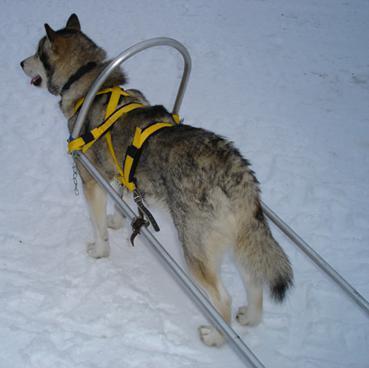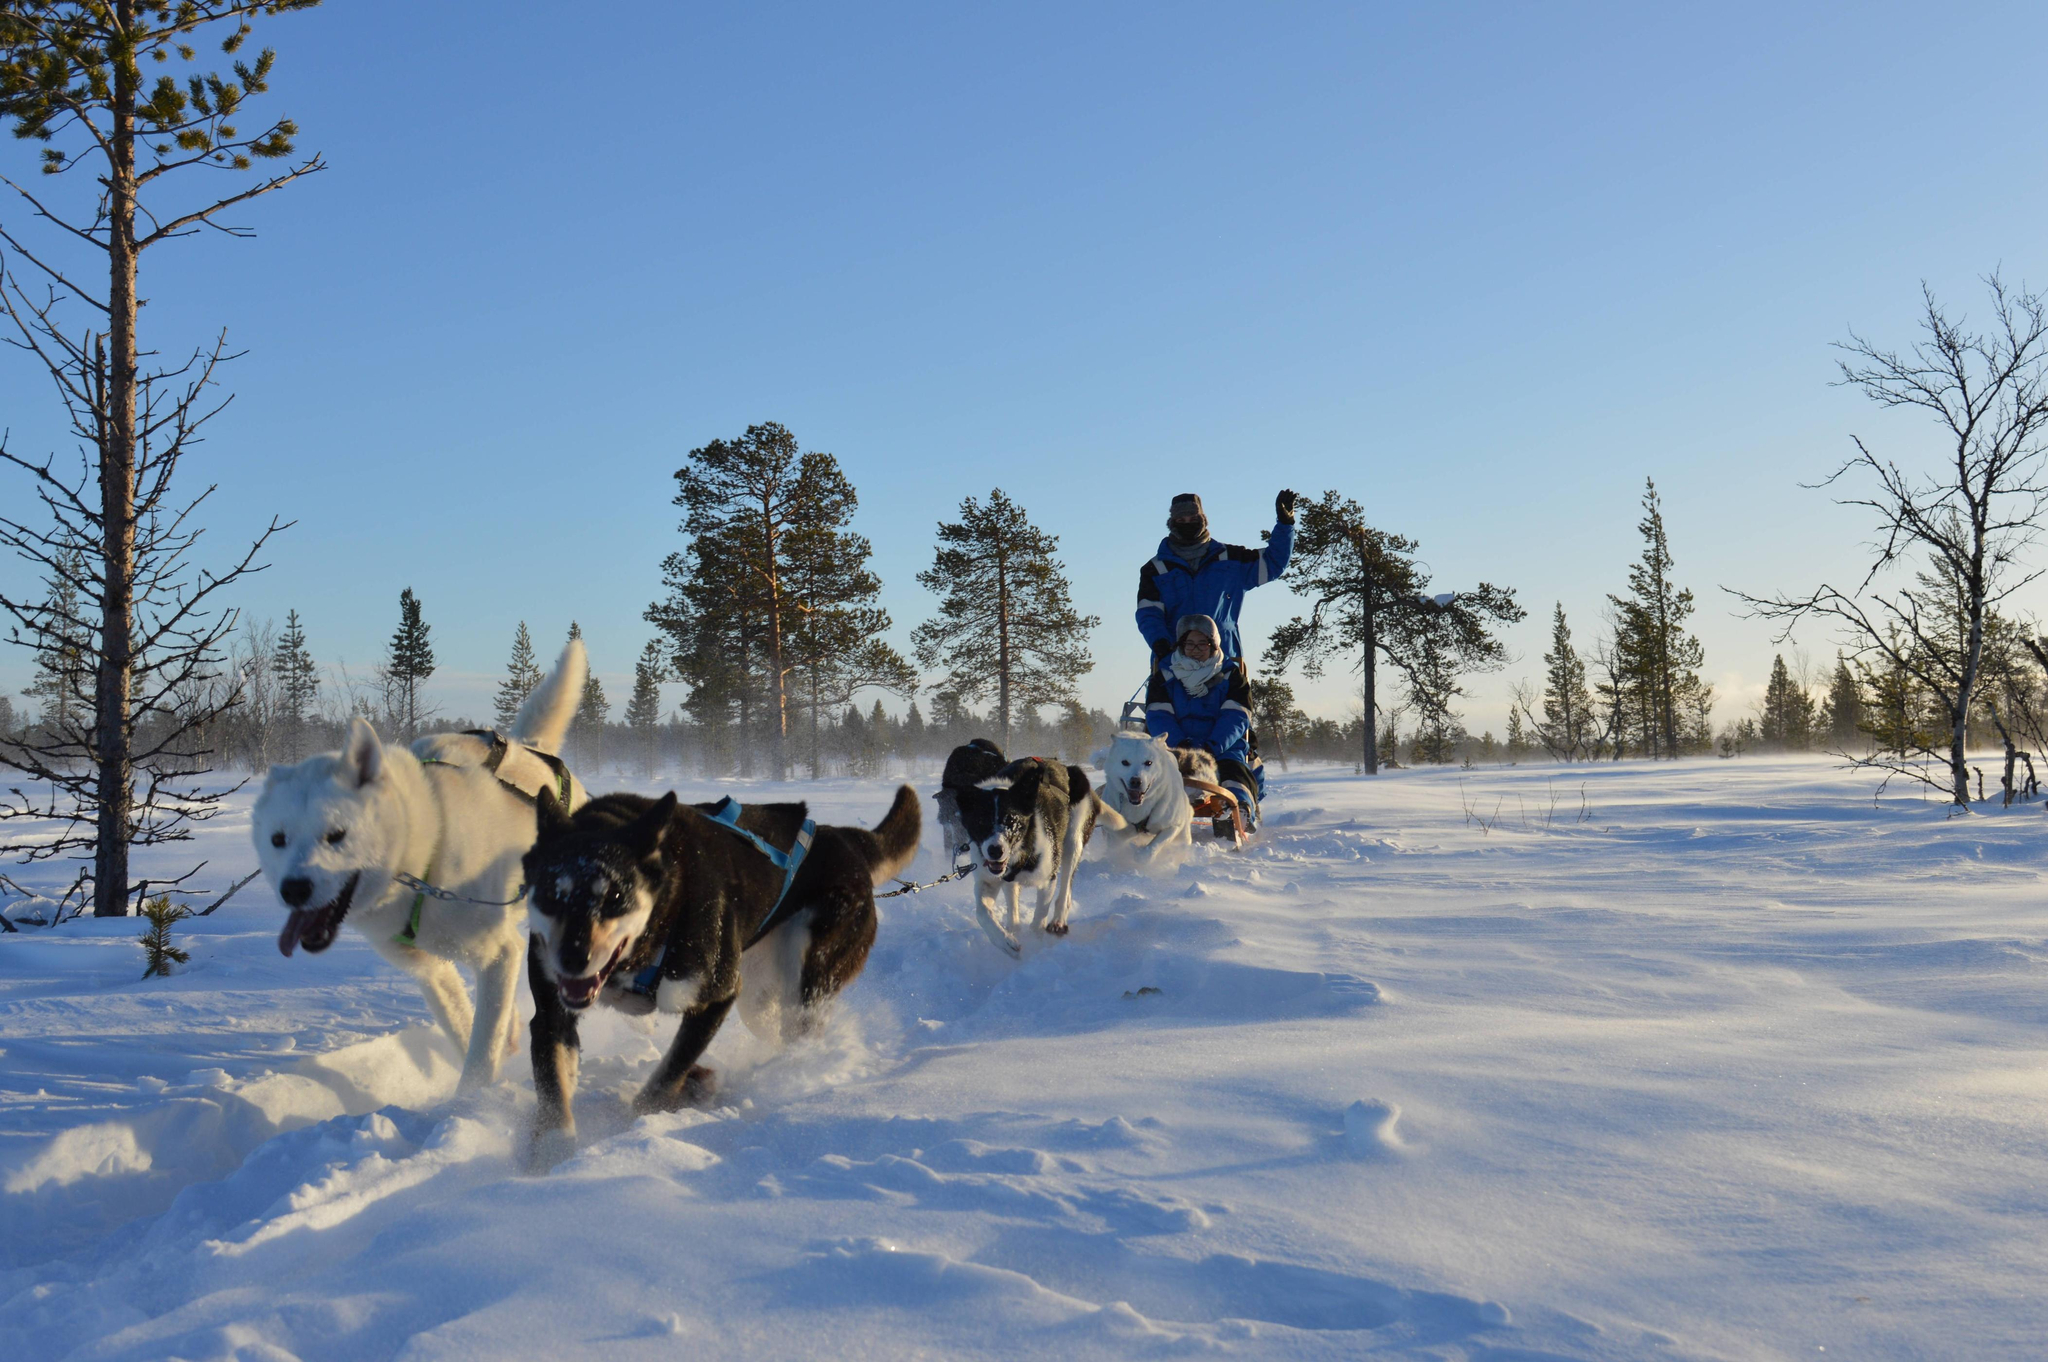The first image is the image on the left, the second image is the image on the right. Examine the images to the left and right. Is the description "An image shows just one dog, which is wearing a harness." accurate? Answer yes or no. Yes. The first image is the image on the left, the second image is the image on the right. Examine the images to the left and right. Is the description "One photo contains a single dog." accurate? Answer yes or no. Yes. 